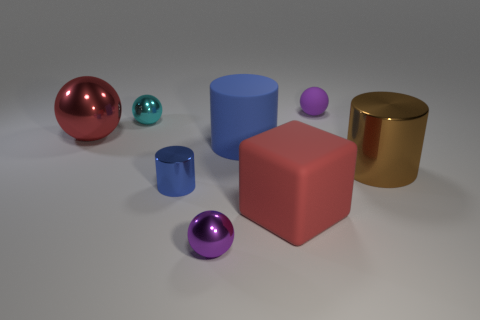How many tiny objects are either blue objects or cyan metal things?
Provide a short and direct response. 2. Are there any other things that have the same color as the small matte sphere?
Your answer should be very brief. Yes. There is a purple thing that is made of the same material as the red ball; what shape is it?
Keep it short and to the point. Sphere. There is a purple ball behind the large red metallic thing; how big is it?
Provide a short and direct response. Small. The big blue thing is what shape?
Provide a succinct answer. Cylinder. Is the size of the metal sphere that is on the right side of the small blue metal cylinder the same as the blue cylinder in front of the big brown cylinder?
Provide a short and direct response. Yes. How big is the purple thing that is in front of the blue object behind the large metal object right of the cyan object?
Offer a terse response. Small. What shape is the large object on the left side of the small purple object that is on the left side of the rubber ball that is behind the red ball?
Ensure brevity in your answer.  Sphere. What shape is the big metallic object right of the big red rubber thing?
Ensure brevity in your answer.  Cylinder. Are the small cyan sphere and the blue cylinder that is on the left side of the small purple metal object made of the same material?
Give a very brief answer. Yes. 